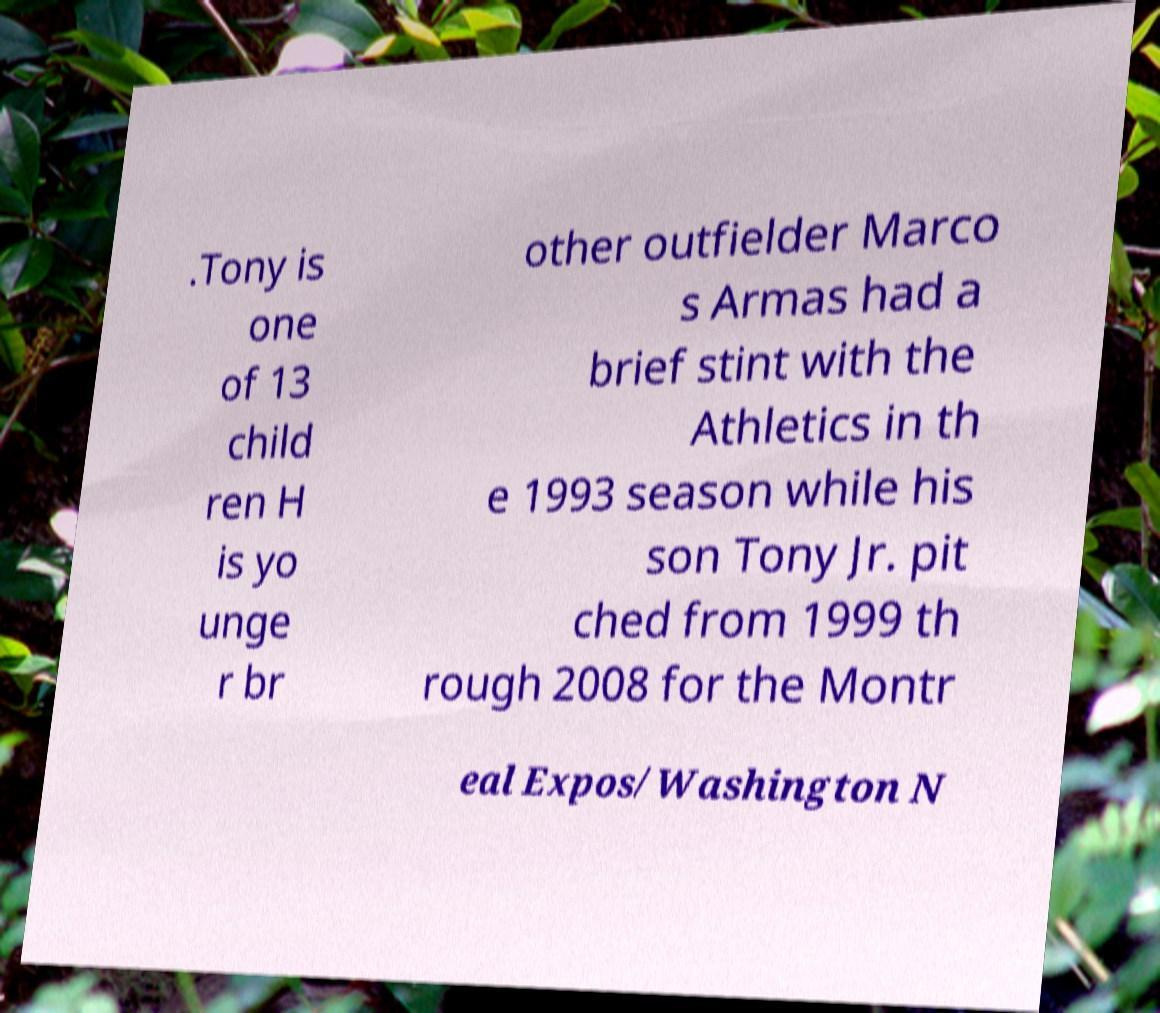Can you accurately transcribe the text from the provided image for me? .Tony is one of 13 child ren H is yo unge r br other outfielder Marco s Armas had a brief stint with the Athletics in th e 1993 season while his son Tony Jr. pit ched from 1999 th rough 2008 for the Montr eal Expos/Washington N 